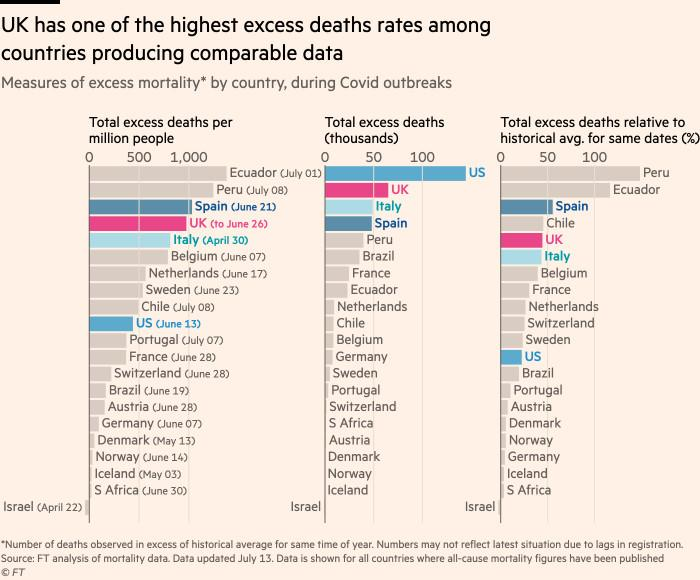Give some essential details in this illustration. The United States surpassed the United Kingdom in terms of total excess deaths, with a higher number of deaths in both countries. According to recent rankings, Ecuador is found to have the highest number of total excess deaths per million people. 